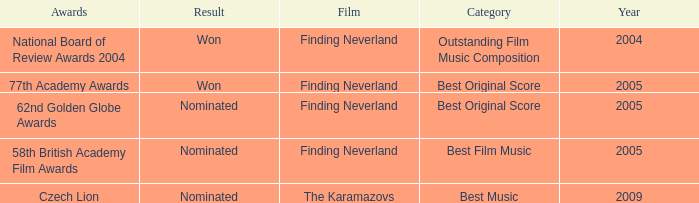What was the result for years prior to 2005? Won. 